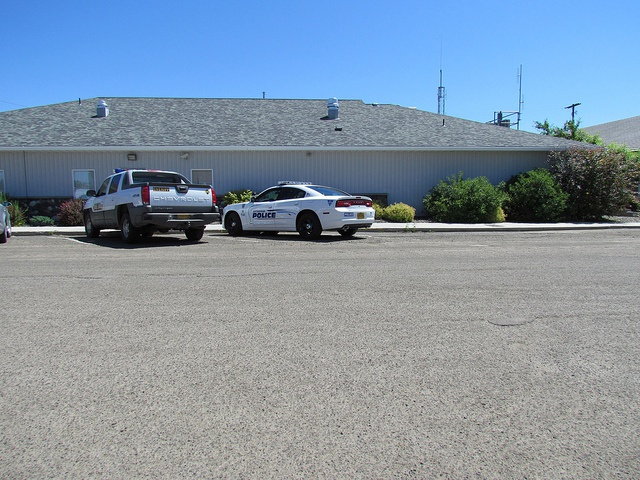Describe the objects in this image and their specific colors. I can see truck in gray and black tones, car in gray and black tones, and car in gray, black, and darkgray tones in this image. 